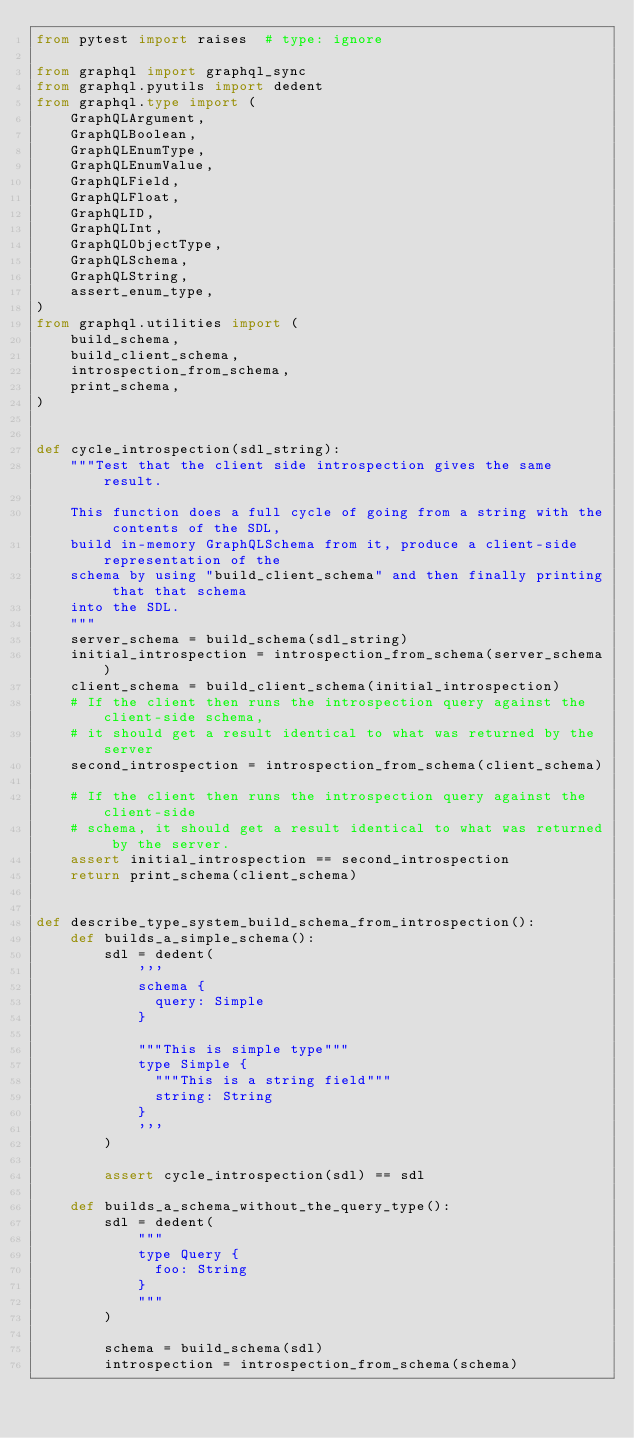<code> <loc_0><loc_0><loc_500><loc_500><_Python_>from pytest import raises  # type: ignore

from graphql import graphql_sync
from graphql.pyutils import dedent
from graphql.type import (
    GraphQLArgument,
    GraphQLBoolean,
    GraphQLEnumType,
    GraphQLEnumValue,
    GraphQLField,
    GraphQLFloat,
    GraphQLID,
    GraphQLInt,
    GraphQLObjectType,
    GraphQLSchema,
    GraphQLString,
    assert_enum_type,
)
from graphql.utilities import (
    build_schema,
    build_client_schema,
    introspection_from_schema,
    print_schema,
)


def cycle_introspection(sdl_string):
    """Test that the client side introspection gives the same result.

    This function does a full cycle of going from a string with the contents of the SDL,
    build in-memory GraphQLSchema from it, produce a client-side representation of the
    schema by using "build_client_schema" and then finally printing that that schema
    into the SDL.
    """
    server_schema = build_schema(sdl_string)
    initial_introspection = introspection_from_schema(server_schema)
    client_schema = build_client_schema(initial_introspection)
    # If the client then runs the introspection query against the client-side schema,
    # it should get a result identical to what was returned by the server
    second_introspection = introspection_from_schema(client_schema)

    # If the client then runs the introspection query against the client-side
    # schema, it should get a result identical to what was returned by the server.
    assert initial_introspection == second_introspection
    return print_schema(client_schema)


def describe_type_system_build_schema_from_introspection():
    def builds_a_simple_schema():
        sdl = dedent(
            '''
            schema {
              query: Simple
            }

            """This is simple type"""
            type Simple {
              """This is a string field"""
              string: String
            }
            '''
        )

        assert cycle_introspection(sdl) == sdl

    def builds_a_schema_without_the_query_type():
        sdl = dedent(
            """
            type Query {
              foo: String
            }
            """
        )

        schema = build_schema(sdl)
        introspection = introspection_from_schema(schema)</code> 